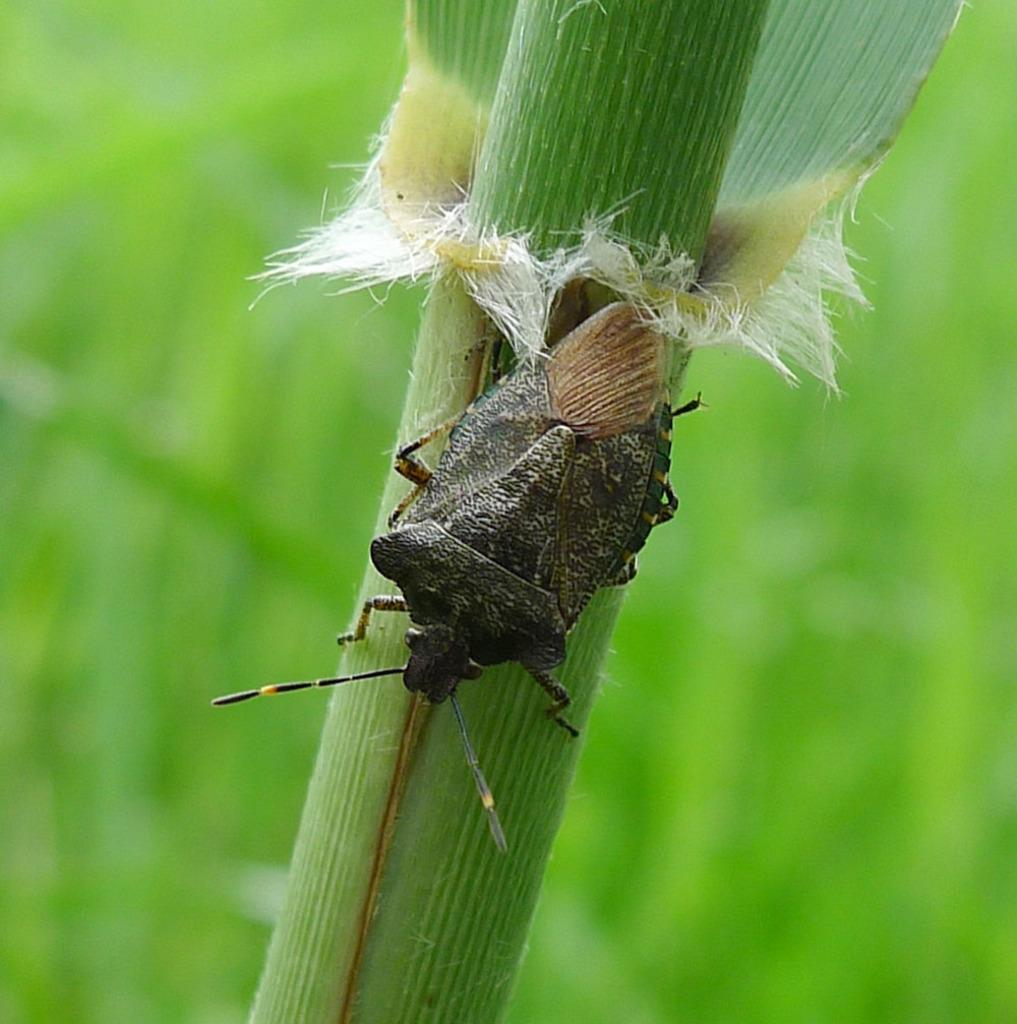What is present in the image that is small and has multiple legs? There is an insect in the image. What is the insect doing in the image? The insect is crawling on the stem of a plant. How is the background of the image depicted? The background of the plant is blurred. What type of coil is being used by the insect to climb the plant in the image? There is no coil present in the image; the insect is crawling on the stem of the plant. How does the insect start its journey in the image? The image does not show the insect starting its journey, only the insect crawling on the stem of the plant. 